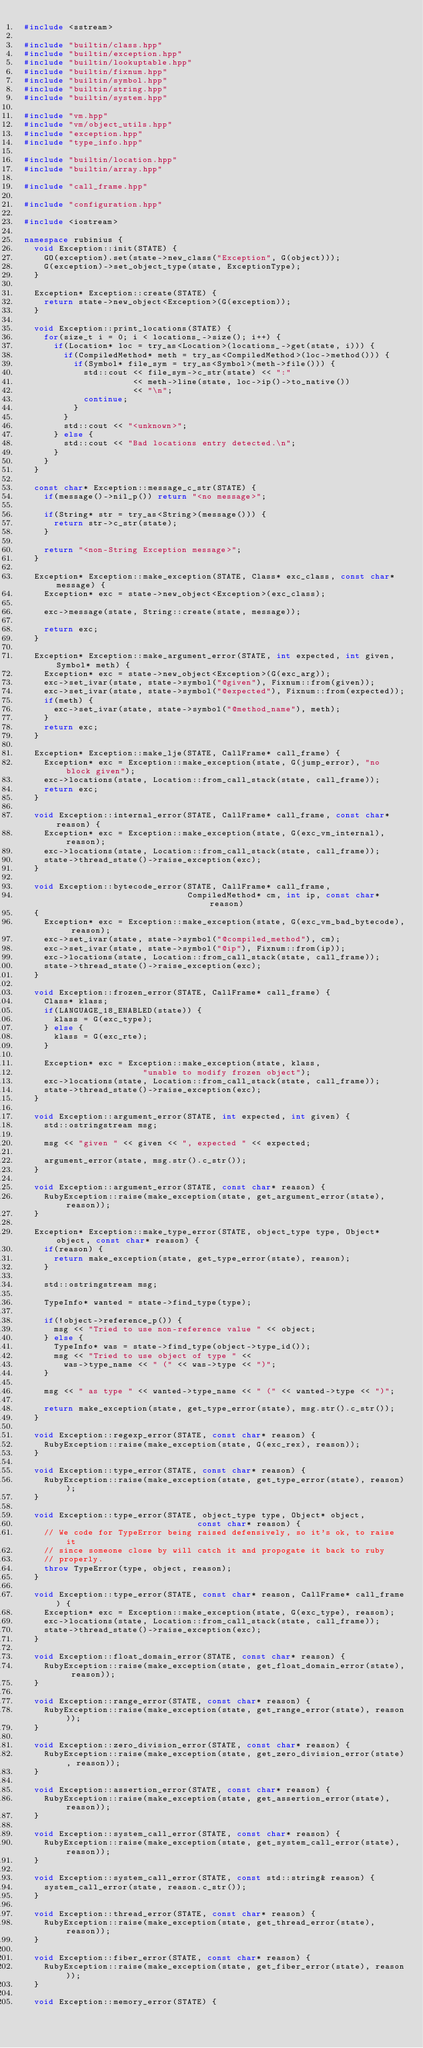<code> <loc_0><loc_0><loc_500><loc_500><_C++_>#include <sstream>

#include "builtin/class.hpp"
#include "builtin/exception.hpp"
#include "builtin/lookuptable.hpp"
#include "builtin/fixnum.hpp"
#include "builtin/symbol.hpp"
#include "builtin/string.hpp"
#include "builtin/system.hpp"

#include "vm.hpp"
#include "vm/object_utils.hpp"
#include "exception.hpp"
#include "type_info.hpp"

#include "builtin/location.hpp"
#include "builtin/array.hpp"

#include "call_frame.hpp"

#include "configuration.hpp"

#include <iostream>

namespace rubinius {
  void Exception::init(STATE) {
    GO(exception).set(state->new_class("Exception", G(object)));
    G(exception)->set_object_type(state, ExceptionType);
  }

  Exception* Exception::create(STATE) {
    return state->new_object<Exception>(G(exception));
  }

  void Exception::print_locations(STATE) {
    for(size_t i = 0; i < locations_->size(); i++) {
      if(Location* loc = try_as<Location>(locations_->get(state, i))) {
        if(CompiledMethod* meth = try_as<CompiledMethod>(loc->method())) {
          if(Symbol* file_sym = try_as<Symbol>(meth->file())) {
            std::cout << file_sym->c_str(state) << ":"
                      << meth->line(state, loc->ip()->to_native())
                      << "\n";
            continue;
          }
        }
        std::cout << "<unknown>";
      } else {
        std::cout << "Bad locations entry detected.\n";
      }
    }
  }

  const char* Exception::message_c_str(STATE) {
    if(message()->nil_p()) return "<no message>";

    if(String* str = try_as<String>(message())) {
      return str->c_str(state);
    }

    return "<non-String Exception message>";
  }

  Exception* Exception::make_exception(STATE, Class* exc_class, const char* message) {
    Exception* exc = state->new_object<Exception>(exc_class);

    exc->message(state, String::create(state, message));

    return exc;
  }

  Exception* Exception::make_argument_error(STATE, int expected, int given, Symbol* meth) {
    Exception* exc = state->new_object<Exception>(G(exc_arg));
    exc->set_ivar(state, state->symbol("@given"), Fixnum::from(given));
    exc->set_ivar(state, state->symbol("@expected"), Fixnum::from(expected));
    if(meth) {
      exc->set_ivar(state, state->symbol("@method_name"), meth);
    }
    return exc;
  }

  Exception* Exception::make_lje(STATE, CallFrame* call_frame) {
    Exception* exc = Exception::make_exception(state, G(jump_error), "no block given");
    exc->locations(state, Location::from_call_stack(state, call_frame));
    return exc;
  }

  void Exception::internal_error(STATE, CallFrame* call_frame, const char* reason) {
    Exception* exc = Exception::make_exception(state, G(exc_vm_internal), reason);
    exc->locations(state, Location::from_call_stack(state, call_frame));
    state->thread_state()->raise_exception(exc);
  }

  void Exception::bytecode_error(STATE, CallFrame* call_frame, 
                                 CompiledMethod* cm, int ip, const char* reason)
  {
    Exception* exc = Exception::make_exception(state, G(exc_vm_bad_bytecode), reason);
    exc->set_ivar(state, state->symbol("@compiled_method"), cm);
    exc->set_ivar(state, state->symbol("@ip"), Fixnum::from(ip));
    exc->locations(state, Location::from_call_stack(state, call_frame));
    state->thread_state()->raise_exception(exc);
  }

  void Exception::frozen_error(STATE, CallFrame* call_frame) {
    Class* klass;
    if(LANGUAGE_18_ENABLED(state)) {
      klass = G(exc_type);
    } else {
      klass = G(exc_rte);
    }

    Exception* exc = Exception::make_exception(state, klass,
                        "unable to modify frozen object");
    exc->locations(state, Location::from_call_stack(state, call_frame));
    state->thread_state()->raise_exception(exc);
  }

  void Exception::argument_error(STATE, int expected, int given) {
    std::ostringstream msg;

    msg << "given " << given << ", expected " << expected;

    argument_error(state, msg.str().c_str());
  }

  void Exception::argument_error(STATE, const char* reason) {
    RubyException::raise(make_exception(state, get_argument_error(state), reason));
  }

  Exception* Exception::make_type_error(STATE, object_type type, Object* object, const char* reason) {
    if(reason) {
      return make_exception(state, get_type_error(state), reason);
    }

    std::ostringstream msg;

    TypeInfo* wanted = state->find_type(type);

    if(!object->reference_p()) {
      msg << "Tried to use non-reference value " << object;
    } else {
      TypeInfo* was = state->find_type(object->type_id());
      msg << "Tried to use object of type " <<
        was->type_name << " (" << was->type << ")";
    }

    msg << " as type " << wanted->type_name << " (" << wanted->type << ")";

    return make_exception(state, get_type_error(state), msg.str().c_str());
  }

  void Exception::regexp_error(STATE, const char* reason) {
    RubyException::raise(make_exception(state, G(exc_rex), reason));
  }

  void Exception::type_error(STATE, const char* reason) {
    RubyException::raise(make_exception(state, get_type_error(state), reason));
  }

  void Exception::type_error(STATE, object_type type, Object* object,
                                   const char* reason) {
    // We code for TypeError being raised defensively, so it's ok, to raise it
    // since someone close by will catch it and propogate it back to ruby
    // properly.
    throw TypeError(type, object, reason);
  }

  void Exception::type_error(STATE, const char* reason, CallFrame* call_frame) {
    Exception* exc = Exception::make_exception(state, G(exc_type), reason);
    exc->locations(state, Location::from_call_stack(state, call_frame));
    state->thread_state()->raise_exception(exc);
  }

  void Exception::float_domain_error(STATE, const char* reason) {
    RubyException::raise(make_exception(state, get_float_domain_error(state), reason));
  }

  void Exception::range_error(STATE, const char* reason) {
    RubyException::raise(make_exception(state, get_range_error(state), reason));
  }

  void Exception::zero_division_error(STATE, const char* reason) {
    RubyException::raise(make_exception(state, get_zero_division_error(state), reason));
  }

  void Exception::assertion_error(STATE, const char* reason) {
    RubyException::raise(make_exception(state, get_assertion_error(state), reason));
  }

  void Exception::system_call_error(STATE, const char* reason) {
    RubyException::raise(make_exception(state, get_system_call_error(state), reason));
  }

  void Exception::system_call_error(STATE, const std::string& reason) {
    system_call_error(state, reason.c_str());
  }

  void Exception::thread_error(STATE, const char* reason) {
    RubyException::raise(make_exception(state, get_thread_error(state), reason));
  }

  void Exception::fiber_error(STATE, const char* reason) {
    RubyException::raise(make_exception(state, get_fiber_error(state), reason));
  }

  void Exception::memory_error(STATE) {</code> 